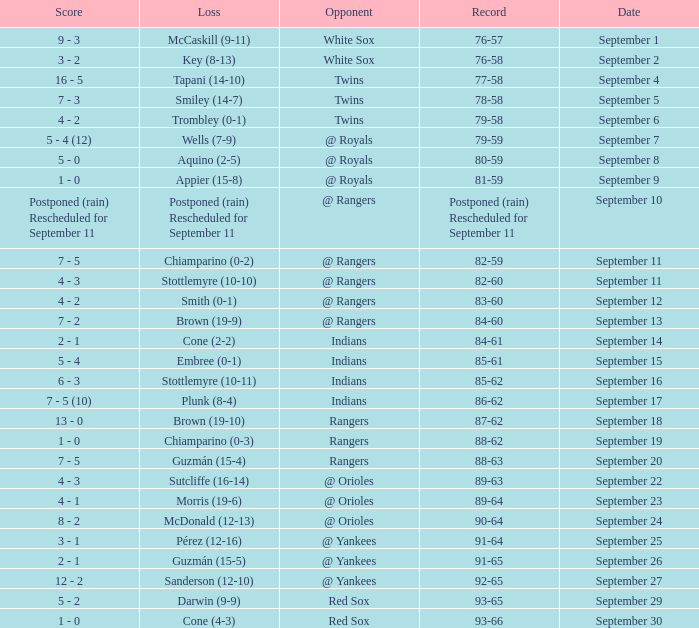What opponent has a record of 86-62? Indians. Could you help me parse every detail presented in this table? {'header': ['Score', 'Loss', 'Opponent', 'Record', 'Date'], 'rows': [['9 - 3', 'McCaskill (9-11)', 'White Sox', '76-57', 'September 1'], ['3 - 2', 'Key (8-13)', 'White Sox', '76-58', 'September 2'], ['16 - 5', 'Tapani (14-10)', 'Twins', '77-58', 'September 4'], ['7 - 3', 'Smiley (14-7)', 'Twins', '78-58', 'September 5'], ['4 - 2', 'Trombley (0-1)', 'Twins', '79-58', 'September 6'], ['5 - 4 (12)', 'Wells (7-9)', '@ Royals', '79-59', 'September 7'], ['5 - 0', 'Aquino (2-5)', '@ Royals', '80-59', 'September 8'], ['1 - 0', 'Appier (15-8)', '@ Royals', '81-59', 'September 9'], ['Postponed (rain) Rescheduled for September 11', 'Postponed (rain) Rescheduled for September 11', '@ Rangers', 'Postponed (rain) Rescheduled for September 11', 'September 10'], ['7 - 5', 'Chiamparino (0-2)', '@ Rangers', '82-59', 'September 11'], ['4 - 3', 'Stottlemyre (10-10)', '@ Rangers', '82-60', 'September 11'], ['4 - 2', 'Smith (0-1)', '@ Rangers', '83-60', 'September 12'], ['7 - 2', 'Brown (19-9)', '@ Rangers', '84-60', 'September 13'], ['2 - 1', 'Cone (2-2)', 'Indians', '84-61', 'September 14'], ['5 - 4', 'Embree (0-1)', 'Indians', '85-61', 'September 15'], ['6 - 3', 'Stottlemyre (10-11)', 'Indians', '85-62', 'September 16'], ['7 - 5 (10)', 'Plunk (8-4)', 'Indians', '86-62', 'September 17'], ['13 - 0', 'Brown (19-10)', 'Rangers', '87-62', 'September 18'], ['1 - 0', 'Chiamparino (0-3)', 'Rangers', '88-62', 'September 19'], ['7 - 5', 'Guzmán (15-4)', 'Rangers', '88-63', 'September 20'], ['4 - 3', 'Sutcliffe (16-14)', '@ Orioles', '89-63', 'September 22'], ['4 - 1', 'Morris (19-6)', '@ Orioles', '89-64', 'September 23'], ['8 - 2', 'McDonald (12-13)', '@ Orioles', '90-64', 'September 24'], ['3 - 1', 'Pérez (12-16)', '@ Yankees', '91-64', 'September 25'], ['2 - 1', 'Guzmán (15-5)', '@ Yankees', '91-65', 'September 26'], ['12 - 2', 'Sanderson (12-10)', '@ Yankees', '92-65', 'September 27'], ['5 - 2', 'Darwin (9-9)', 'Red Sox', '93-65', 'September 29'], ['1 - 0', 'Cone (4-3)', 'Red Sox', '93-66', 'September 30']]} 